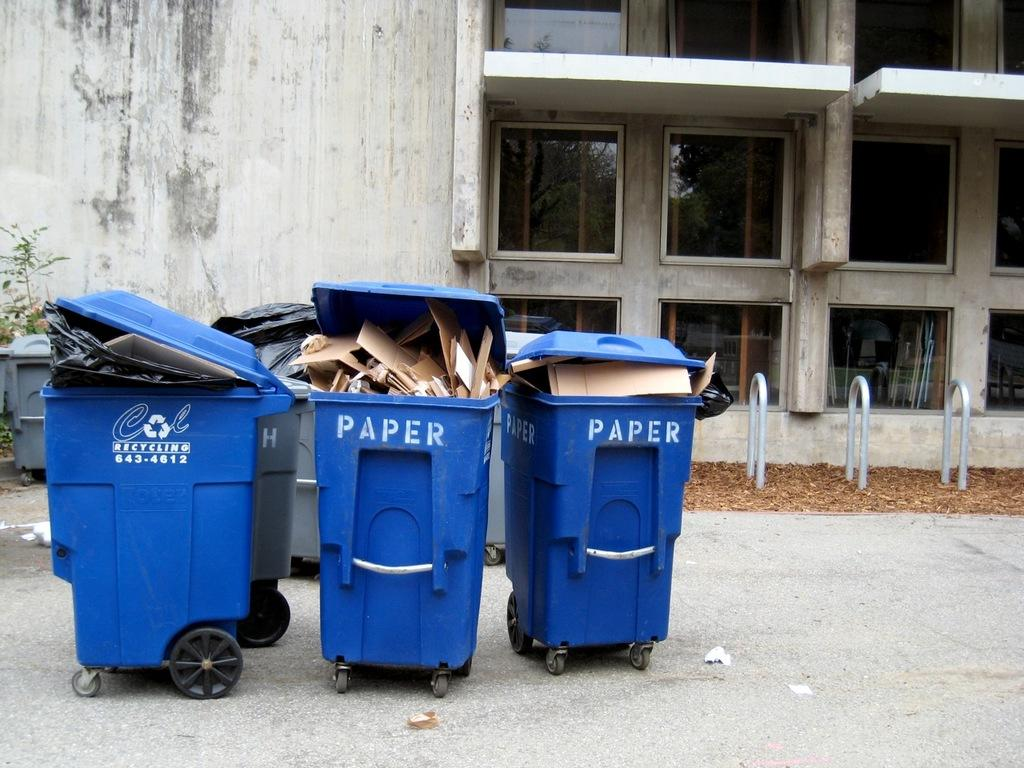Provide a one-sentence caption for the provided image. Three blue wheelie bins, two of which have paper written on the front. 